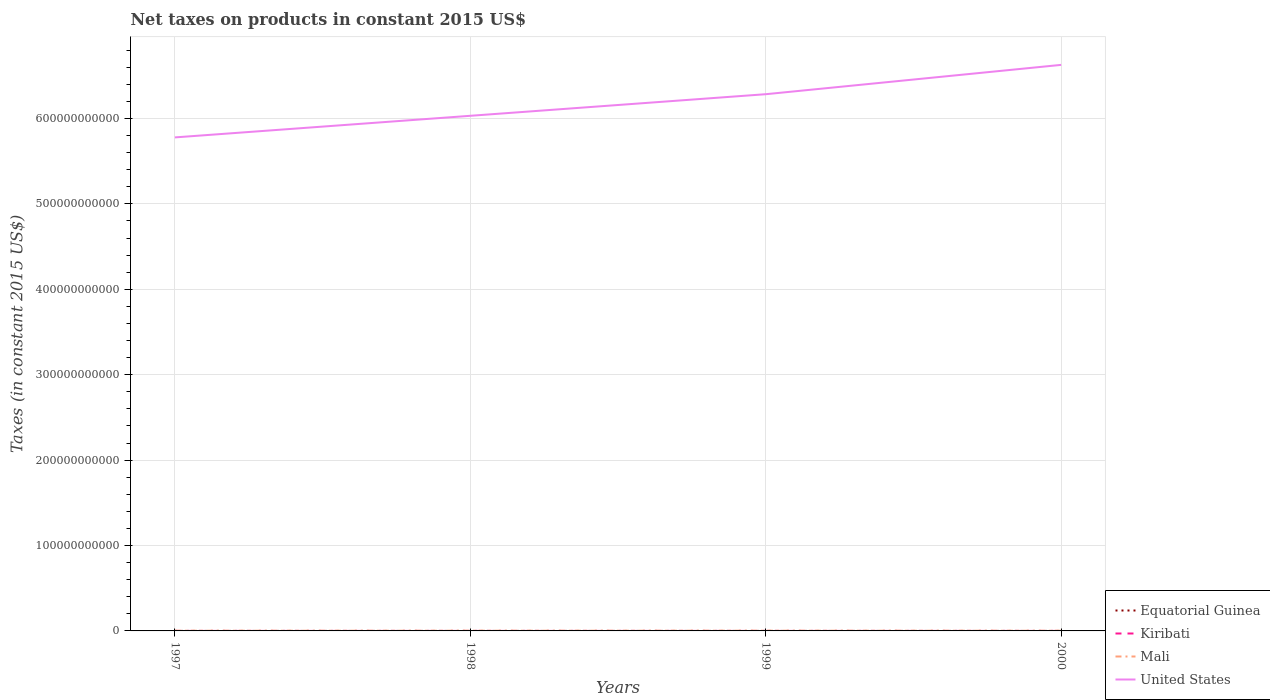How many different coloured lines are there?
Ensure brevity in your answer.  4. Does the line corresponding to Kiribati intersect with the line corresponding to Equatorial Guinea?
Provide a succinct answer. No. Is the number of lines equal to the number of legend labels?
Provide a short and direct response. Yes. Across all years, what is the maximum net taxes on products in Mali?
Offer a very short reply. 2.16e+08. What is the total net taxes on products in Kiribati in the graph?
Your answer should be very brief. 1.41e+06. What is the difference between the highest and the second highest net taxes on products in United States?
Offer a very short reply. 8.49e+1. Is the net taxes on products in Equatorial Guinea strictly greater than the net taxes on products in Kiribati over the years?
Provide a short and direct response. No. How many lines are there?
Offer a terse response. 4. How many years are there in the graph?
Provide a short and direct response. 4. What is the difference between two consecutive major ticks on the Y-axis?
Ensure brevity in your answer.  1.00e+11. Does the graph contain any zero values?
Offer a terse response. No. Does the graph contain grids?
Make the answer very short. Yes. Where does the legend appear in the graph?
Provide a short and direct response. Bottom right. How many legend labels are there?
Your answer should be very brief. 4. What is the title of the graph?
Your answer should be very brief. Net taxes on products in constant 2015 US$. What is the label or title of the X-axis?
Offer a terse response. Years. What is the label or title of the Y-axis?
Provide a short and direct response. Taxes (in constant 2015 US$). What is the Taxes (in constant 2015 US$) in Equatorial Guinea in 1997?
Keep it short and to the point. 9.47e+06. What is the Taxes (in constant 2015 US$) of Kiribati in 1997?
Offer a terse response. 6.02e+06. What is the Taxes (in constant 2015 US$) in Mali in 1997?
Your answer should be very brief. 2.32e+08. What is the Taxes (in constant 2015 US$) of United States in 1997?
Make the answer very short. 5.78e+11. What is the Taxes (in constant 2015 US$) in Equatorial Guinea in 1998?
Provide a short and direct response. 1.10e+07. What is the Taxes (in constant 2015 US$) of Kiribati in 1998?
Your answer should be compact. 4.61e+06. What is the Taxes (in constant 2015 US$) in Mali in 1998?
Your response must be concise. 2.47e+08. What is the Taxes (in constant 2015 US$) of United States in 1998?
Provide a succinct answer. 6.03e+11. What is the Taxes (in constant 2015 US$) of Equatorial Guinea in 1999?
Your answer should be compact. 1.16e+07. What is the Taxes (in constant 2015 US$) in Kiribati in 1999?
Keep it short and to the point. 2.83e+06. What is the Taxes (in constant 2015 US$) in Mali in 1999?
Provide a succinct answer. 2.73e+08. What is the Taxes (in constant 2015 US$) of United States in 1999?
Your answer should be very brief. 6.28e+11. What is the Taxes (in constant 2015 US$) in Equatorial Guinea in 2000?
Ensure brevity in your answer.  1.10e+07. What is the Taxes (in constant 2015 US$) of Kiribati in 2000?
Give a very brief answer. 7.83e+06. What is the Taxes (in constant 2015 US$) in Mali in 2000?
Keep it short and to the point. 2.16e+08. What is the Taxes (in constant 2015 US$) of United States in 2000?
Provide a short and direct response. 6.63e+11. Across all years, what is the maximum Taxes (in constant 2015 US$) of Equatorial Guinea?
Your answer should be compact. 1.16e+07. Across all years, what is the maximum Taxes (in constant 2015 US$) of Kiribati?
Your answer should be compact. 7.83e+06. Across all years, what is the maximum Taxes (in constant 2015 US$) in Mali?
Offer a terse response. 2.73e+08. Across all years, what is the maximum Taxes (in constant 2015 US$) of United States?
Make the answer very short. 6.63e+11. Across all years, what is the minimum Taxes (in constant 2015 US$) in Equatorial Guinea?
Ensure brevity in your answer.  9.47e+06. Across all years, what is the minimum Taxes (in constant 2015 US$) in Kiribati?
Your answer should be very brief. 2.83e+06. Across all years, what is the minimum Taxes (in constant 2015 US$) of Mali?
Ensure brevity in your answer.  2.16e+08. Across all years, what is the minimum Taxes (in constant 2015 US$) in United States?
Offer a very short reply. 5.78e+11. What is the total Taxes (in constant 2015 US$) in Equatorial Guinea in the graph?
Your answer should be very brief. 4.31e+07. What is the total Taxes (in constant 2015 US$) of Kiribati in the graph?
Provide a succinct answer. 2.13e+07. What is the total Taxes (in constant 2015 US$) of Mali in the graph?
Provide a succinct answer. 9.68e+08. What is the total Taxes (in constant 2015 US$) in United States in the graph?
Your answer should be very brief. 2.47e+12. What is the difference between the Taxes (in constant 2015 US$) in Equatorial Guinea in 1997 and that in 1998?
Give a very brief answer. -1.55e+06. What is the difference between the Taxes (in constant 2015 US$) of Kiribati in 1997 and that in 1998?
Your response must be concise. 1.41e+06. What is the difference between the Taxes (in constant 2015 US$) of Mali in 1997 and that in 1998?
Your answer should be compact. -1.52e+07. What is the difference between the Taxes (in constant 2015 US$) in United States in 1997 and that in 1998?
Provide a short and direct response. -2.53e+1. What is the difference between the Taxes (in constant 2015 US$) of Equatorial Guinea in 1997 and that in 1999?
Give a very brief answer. -2.17e+06. What is the difference between the Taxes (in constant 2015 US$) in Kiribati in 1997 and that in 1999?
Make the answer very short. 3.19e+06. What is the difference between the Taxes (in constant 2015 US$) of Mali in 1997 and that in 1999?
Your response must be concise. -4.05e+07. What is the difference between the Taxes (in constant 2015 US$) of United States in 1997 and that in 1999?
Offer a terse response. -5.06e+1. What is the difference between the Taxes (in constant 2015 US$) of Equatorial Guinea in 1997 and that in 2000?
Make the answer very short. -1.52e+06. What is the difference between the Taxes (in constant 2015 US$) of Kiribati in 1997 and that in 2000?
Your response must be concise. -1.81e+06. What is the difference between the Taxes (in constant 2015 US$) of Mali in 1997 and that in 2000?
Ensure brevity in your answer.  1.67e+07. What is the difference between the Taxes (in constant 2015 US$) in United States in 1997 and that in 2000?
Your answer should be very brief. -8.49e+1. What is the difference between the Taxes (in constant 2015 US$) of Equatorial Guinea in 1998 and that in 1999?
Make the answer very short. -6.18e+05. What is the difference between the Taxes (in constant 2015 US$) of Kiribati in 1998 and that in 1999?
Your response must be concise. 1.78e+06. What is the difference between the Taxes (in constant 2015 US$) of Mali in 1998 and that in 1999?
Your response must be concise. -2.53e+07. What is the difference between the Taxes (in constant 2015 US$) in United States in 1998 and that in 1999?
Give a very brief answer. -2.53e+1. What is the difference between the Taxes (in constant 2015 US$) of Equatorial Guinea in 1998 and that in 2000?
Ensure brevity in your answer.  3.18e+04. What is the difference between the Taxes (in constant 2015 US$) of Kiribati in 1998 and that in 2000?
Your answer should be compact. -3.22e+06. What is the difference between the Taxes (in constant 2015 US$) of Mali in 1998 and that in 2000?
Your response must be concise. 3.19e+07. What is the difference between the Taxes (in constant 2015 US$) of United States in 1998 and that in 2000?
Provide a succinct answer. -5.96e+1. What is the difference between the Taxes (in constant 2015 US$) in Equatorial Guinea in 1999 and that in 2000?
Give a very brief answer. 6.49e+05. What is the difference between the Taxes (in constant 2015 US$) of Kiribati in 1999 and that in 2000?
Make the answer very short. -5.00e+06. What is the difference between the Taxes (in constant 2015 US$) of Mali in 1999 and that in 2000?
Provide a succinct answer. 5.72e+07. What is the difference between the Taxes (in constant 2015 US$) of United States in 1999 and that in 2000?
Provide a succinct answer. -3.43e+1. What is the difference between the Taxes (in constant 2015 US$) in Equatorial Guinea in 1997 and the Taxes (in constant 2015 US$) in Kiribati in 1998?
Your response must be concise. 4.86e+06. What is the difference between the Taxes (in constant 2015 US$) of Equatorial Guinea in 1997 and the Taxes (in constant 2015 US$) of Mali in 1998?
Provide a succinct answer. -2.38e+08. What is the difference between the Taxes (in constant 2015 US$) in Equatorial Guinea in 1997 and the Taxes (in constant 2015 US$) in United States in 1998?
Make the answer very short. -6.03e+11. What is the difference between the Taxes (in constant 2015 US$) of Kiribati in 1997 and the Taxes (in constant 2015 US$) of Mali in 1998?
Your answer should be compact. -2.41e+08. What is the difference between the Taxes (in constant 2015 US$) in Kiribati in 1997 and the Taxes (in constant 2015 US$) in United States in 1998?
Make the answer very short. -6.03e+11. What is the difference between the Taxes (in constant 2015 US$) in Mali in 1997 and the Taxes (in constant 2015 US$) in United States in 1998?
Provide a succinct answer. -6.03e+11. What is the difference between the Taxes (in constant 2015 US$) in Equatorial Guinea in 1997 and the Taxes (in constant 2015 US$) in Kiribati in 1999?
Provide a short and direct response. 6.64e+06. What is the difference between the Taxes (in constant 2015 US$) of Equatorial Guinea in 1997 and the Taxes (in constant 2015 US$) of Mali in 1999?
Make the answer very short. -2.63e+08. What is the difference between the Taxes (in constant 2015 US$) of Equatorial Guinea in 1997 and the Taxes (in constant 2015 US$) of United States in 1999?
Keep it short and to the point. -6.28e+11. What is the difference between the Taxes (in constant 2015 US$) in Kiribati in 1997 and the Taxes (in constant 2015 US$) in Mali in 1999?
Offer a very short reply. -2.67e+08. What is the difference between the Taxes (in constant 2015 US$) of Kiribati in 1997 and the Taxes (in constant 2015 US$) of United States in 1999?
Your answer should be compact. -6.28e+11. What is the difference between the Taxes (in constant 2015 US$) in Mali in 1997 and the Taxes (in constant 2015 US$) in United States in 1999?
Your answer should be very brief. -6.28e+11. What is the difference between the Taxes (in constant 2015 US$) of Equatorial Guinea in 1997 and the Taxes (in constant 2015 US$) of Kiribati in 2000?
Ensure brevity in your answer.  1.64e+06. What is the difference between the Taxes (in constant 2015 US$) in Equatorial Guinea in 1997 and the Taxes (in constant 2015 US$) in Mali in 2000?
Your answer should be very brief. -2.06e+08. What is the difference between the Taxes (in constant 2015 US$) of Equatorial Guinea in 1997 and the Taxes (in constant 2015 US$) of United States in 2000?
Your answer should be very brief. -6.63e+11. What is the difference between the Taxes (in constant 2015 US$) in Kiribati in 1997 and the Taxes (in constant 2015 US$) in Mali in 2000?
Your answer should be compact. -2.10e+08. What is the difference between the Taxes (in constant 2015 US$) of Kiribati in 1997 and the Taxes (in constant 2015 US$) of United States in 2000?
Your answer should be very brief. -6.63e+11. What is the difference between the Taxes (in constant 2015 US$) in Mali in 1997 and the Taxes (in constant 2015 US$) in United States in 2000?
Provide a succinct answer. -6.62e+11. What is the difference between the Taxes (in constant 2015 US$) of Equatorial Guinea in 1998 and the Taxes (in constant 2015 US$) of Kiribati in 1999?
Your response must be concise. 8.19e+06. What is the difference between the Taxes (in constant 2015 US$) in Equatorial Guinea in 1998 and the Taxes (in constant 2015 US$) in Mali in 1999?
Your response must be concise. -2.62e+08. What is the difference between the Taxes (in constant 2015 US$) in Equatorial Guinea in 1998 and the Taxes (in constant 2015 US$) in United States in 1999?
Give a very brief answer. -6.28e+11. What is the difference between the Taxes (in constant 2015 US$) of Kiribati in 1998 and the Taxes (in constant 2015 US$) of Mali in 1999?
Your answer should be very brief. -2.68e+08. What is the difference between the Taxes (in constant 2015 US$) of Kiribati in 1998 and the Taxes (in constant 2015 US$) of United States in 1999?
Offer a terse response. -6.28e+11. What is the difference between the Taxes (in constant 2015 US$) of Mali in 1998 and the Taxes (in constant 2015 US$) of United States in 1999?
Give a very brief answer. -6.28e+11. What is the difference between the Taxes (in constant 2015 US$) in Equatorial Guinea in 1998 and the Taxes (in constant 2015 US$) in Kiribati in 2000?
Make the answer very short. 3.19e+06. What is the difference between the Taxes (in constant 2015 US$) in Equatorial Guinea in 1998 and the Taxes (in constant 2015 US$) in Mali in 2000?
Offer a very short reply. -2.05e+08. What is the difference between the Taxes (in constant 2015 US$) of Equatorial Guinea in 1998 and the Taxes (in constant 2015 US$) of United States in 2000?
Your response must be concise. -6.63e+11. What is the difference between the Taxes (in constant 2015 US$) in Kiribati in 1998 and the Taxes (in constant 2015 US$) in Mali in 2000?
Your answer should be compact. -2.11e+08. What is the difference between the Taxes (in constant 2015 US$) of Kiribati in 1998 and the Taxes (in constant 2015 US$) of United States in 2000?
Give a very brief answer. -6.63e+11. What is the difference between the Taxes (in constant 2015 US$) in Mali in 1998 and the Taxes (in constant 2015 US$) in United States in 2000?
Your answer should be compact. -6.62e+11. What is the difference between the Taxes (in constant 2015 US$) in Equatorial Guinea in 1999 and the Taxes (in constant 2015 US$) in Kiribati in 2000?
Your answer should be very brief. 3.81e+06. What is the difference between the Taxes (in constant 2015 US$) of Equatorial Guinea in 1999 and the Taxes (in constant 2015 US$) of Mali in 2000?
Ensure brevity in your answer.  -2.04e+08. What is the difference between the Taxes (in constant 2015 US$) in Equatorial Guinea in 1999 and the Taxes (in constant 2015 US$) in United States in 2000?
Provide a succinct answer. -6.63e+11. What is the difference between the Taxes (in constant 2015 US$) of Kiribati in 1999 and the Taxes (in constant 2015 US$) of Mali in 2000?
Offer a terse response. -2.13e+08. What is the difference between the Taxes (in constant 2015 US$) in Kiribati in 1999 and the Taxes (in constant 2015 US$) in United States in 2000?
Offer a very short reply. -6.63e+11. What is the difference between the Taxes (in constant 2015 US$) of Mali in 1999 and the Taxes (in constant 2015 US$) of United States in 2000?
Your response must be concise. -6.62e+11. What is the average Taxes (in constant 2015 US$) in Equatorial Guinea per year?
Your answer should be very brief. 1.08e+07. What is the average Taxes (in constant 2015 US$) in Kiribati per year?
Keep it short and to the point. 5.32e+06. What is the average Taxes (in constant 2015 US$) in Mali per year?
Give a very brief answer. 2.42e+08. What is the average Taxes (in constant 2015 US$) in United States per year?
Make the answer very short. 6.18e+11. In the year 1997, what is the difference between the Taxes (in constant 2015 US$) in Equatorial Guinea and Taxes (in constant 2015 US$) in Kiribati?
Your response must be concise. 3.45e+06. In the year 1997, what is the difference between the Taxes (in constant 2015 US$) of Equatorial Guinea and Taxes (in constant 2015 US$) of Mali?
Provide a short and direct response. -2.23e+08. In the year 1997, what is the difference between the Taxes (in constant 2015 US$) in Equatorial Guinea and Taxes (in constant 2015 US$) in United States?
Offer a very short reply. -5.78e+11. In the year 1997, what is the difference between the Taxes (in constant 2015 US$) in Kiribati and Taxes (in constant 2015 US$) in Mali?
Make the answer very short. -2.26e+08. In the year 1997, what is the difference between the Taxes (in constant 2015 US$) in Kiribati and Taxes (in constant 2015 US$) in United States?
Offer a very short reply. -5.78e+11. In the year 1997, what is the difference between the Taxes (in constant 2015 US$) in Mali and Taxes (in constant 2015 US$) in United States?
Give a very brief answer. -5.78e+11. In the year 1998, what is the difference between the Taxes (in constant 2015 US$) of Equatorial Guinea and Taxes (in constant 2015 US$) of Kiribati?
Provide a short and direct response. 6.41e+06. In the year 1998, what is the difference between the Taxes (in constant 2015 US$) of Equatorial Guinea and Taxes (in constant 2015 US$) of Mali?
Keep it short and to the point. -2.36e+08. In the year 1998, what is the difference between the Taxes (in constant 2015 US$) of Equatorial Guinea and Taxes (in constant 2015 US$) of United States?
Provide a succinct answer. -6.03e+11. In the year 1998, what is the difference between the Taxes (in constant 2015 US$) in Kiribati and Taxes (in constant 2015 US$) in Mali?
Keep it short and to the point. -2.43e+08. In the year 1998, what is the difference between the Taxes (in constant 2015 US$) of Kiribati and Taxes (in constant 2015 US$) of United States?
Keep it short and to the point. -6.03e+11. In the year 1998, what is the difference between the Taxes (in constant 2015 US$) in Mali and Taxes (in constant 2015 US$) in United States?
Your answer should be compact. -6.03e+11. In the year 1999, what is the difference between the Taxes (in constant 2015 US$) in Equatorial Guinea and Taxes (in constant 2015 US$) in Kiribati?
Keep it short and to the point. 8.81e+06. In the year 1999, what is the difference between the Taxes (in constant 2015 US$) of Equatorial Guinea and Taxes (in constant 2015 US$) of Mali?
Offer a very short reply. -2.61e+08. In the year 1999, what is the difference between the Taxes (in constant 2015 US$) of Equatorial Guinea and Taxes (in constant 2015 US$) of United States?
Keep it short and to the point. -6.28e+11. In the year 1999, what is the difference between the Taxes (in constant 2015 US$) in Kiribati and Taxes (in constant 2015 US$) in Mali?
Your answer should be compact. -2.70e+08. In the year 1999, what is the difference between the Taxes (in constant 2015 US$) in Kiribati and Taxes (in constant 2015 US$) in United States?
Keep it short and to the point. -6.28e+11. In the year 1999, what is the difference between the Taxes (in constant 2015 US$) in Mali and Taxes (in constant 2015 US$) in United States?
Make the answer very short. -6.28e+11. In the year 2000, what is the difference between the Taxes (in constant 2015 US$) in Equatorial Guinea and Taxes (in constant 2015 US$) in Kiribati?
Your answer should be very brief. 3.16e+06. In the year 2000, what is the difference between the Taxes (in constant 2015 US$) of Equatorial Guinea and Taxes (in constant 2015 US$) of Mali?
Your answer should be compact. -2.05e+08. In the year 2000, what is the difference between the Taxes (in constant 2015 US$) of Equatorial Guinea and Taxes (in constant 2015 US$) of United States?
Provide a short and direct response. -6.63e+11. In the year 2000, what is the difference between the Taxes (in constant 2015 US$) of Kiribati and Taxes (in constant 2015 US$) of Mali?
Offer a terse response. -2.08e+08. In the year 2000, what is the difference between the Taxes (in constant 2015 US$) of Kiribati and Taxes (in constant 2015 US$) of United States?
Give a very brief answer. -6.63e+11. In the year 2000, what is the difference between the Taxes (in constant 2015 US$) of Mali and Taxes (in constant 2015 US$) of United States?
Ensure brevity in your answer.  -6.63e+11. What is the ratio of the Taxes (in constant 2015 US$) of Equatorial Guinea in 1997 to that in 1998?
Keep it short and to the point. 0.86. What is the ratio of the Taxes (in constant 2015 US$) in Kiribati in 1997 to that in 1998?
Make the answer very short. 1.31. What is the ratio of the Taxes (in constant 2015 US$) in Mali in 1997 to that in 1998?
Give a very brief answer. 0.94. What is the ratio of the Taxes (in constant 2015 US$) in United States in 1997 to that in 1998?
Provide a succinct answer. 0.96. What is the ratio of the Taxes (in constant 2015 US$) in Equatorial Guinea in 1997 to that in 1999?
Your response must be concise. 0.81. What is the ratio of the Taxes (in constant 2015 US$) of Kiribati in 1997 to that in 1999?
Give a very brief answer. 2.13. What is the ratio of the Taxes (in constant 2015 US$) in Mali in 1997 to that in 1999?
Give a very brief answer. 0.85. What is the ratio of the Taxes (in constant 2015 US$) of United States in 1997 to that in 1999?
Your answer should be very brief. 0.92. What is the ratio of the Taxes (in constant 2015 US$) in Equatorial Guinea in 1997 to that in 2000?
Provide a short and direct response. 0.86. What is the ratio of the Taxes (in constant 2015 US$) in Kiribati in 1997 to that in 2000?
Your answer should be very brief. 0.77. What is the ratio of the Taxes (in constant 2015 US$) of Mali in 1997 to that in 2000?
Give a very brief answer. 1.08. What is the ratio of the Taxes (in constant 2015 US$) in United States in 1997 to that in 2000?
Give a very brief answer. 0.87. What is the ratio of the Taxes (in constant 2015 US$) of Equatorial Guinea in 1998 to that in 1999?
Make the answer very short. 0.95. What is the ratio of the Taxes (in constant 2015 US$) of Kiribati in 1998 to that in 1999?
Offer a very short reply. 1.63. What is the ratio of the Taxes (in constant 2015 US$) of Mali in 1998 to that in 1999?
Provide a succinct answer. 0.91. What is the ratio of the Taxes (in constant 2015 US$) in United States in 1998 to that in 1999?
Give a very brief answer. 0.96. What is the ratio of the Taxes (in constant 2015 US$) of Kiribati in 1998 to that in 2000?
Provide a short and direct response. 0.59. What is the ratio of the Taxes (in constant 2015 US$) of Mali in 1998 to that in 2000?
Offer a terse response. 1.15. What is the ratio of the Taxes (in constant 2015 US$) in United States in 1998 to that in 2000?
Keep it short and to the point. 0.91. What is the ratio of the Taxes (in constant 2015 US$) in Equatorial Guinea in 1999 to that in 2000?
Provide a short and direct response. 1.06. What is the ratio of the Taxes (in constant 2015 US$) in Kiribati in 1999 to that in 2000?
Provide a succinct answer. 0.36. What is the ratio of the Taxes (in constant 2015 US$) in Mali in 1999 to that in 2000?
Your answer should be compact. 1.27. What is the ratio of the Taxes (in constant 2015 US$) in United States in 1999 to that in 2000?
Your answer should be very brief. 0.95. What is the difference between the highest and the second highest Taxes (in constant 2015 US$) of Equatorial Guinea?
Your answer should be compact. 6.18e+05. What is the difference between the highest and the second highest Taxes (in constant 2015 US$) of Kiribati?
Your answer should be very brief. 1.81e+06. What is the difference between the highest and the second highest Taxes (in constant 2015 US$) in Mali?
Offer a very short reply. 2.53e+07. What is the difference between the highest and the second highest Taxes (in constant 2015 US$) of United States?
Offer a terse response. 3.43e+1. What is the difference between the highest and the lowest Taxes (in constant 2015 US$) in Equatorial Guinea?
Your answer should be compact. 2.17e+06. What is the difference between the highest and the lowest Taxes (in constant 2015 US$) of Kiribati?
Your response must be concise. 5.00e+06. What is the difference between the highest and the lowest Taxes (in constant 2015 US$) in Mali?
Your response must be concise. 5.72e+07. What is the difference between the highest and the lowest Taxes (in constant 2015 US$) of United States?
Offer a terse response. 8.49e+1. 